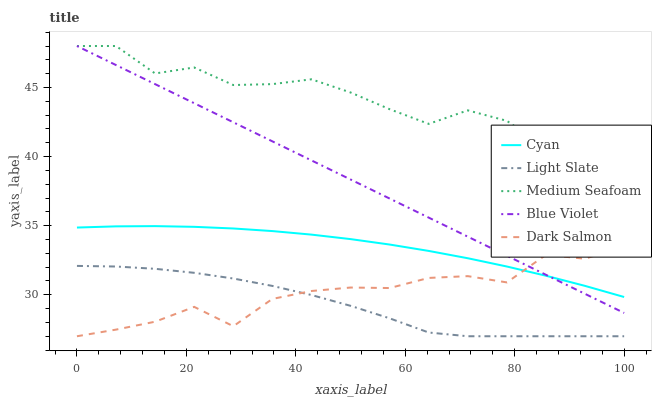Does Light Slate have the minimum area under the curve?
Answer yes or no. Yes. Does Medium Seafoam have the maximum area under the curve?
Answer yes or no. Yes. Does Cyan have the minimum area under the curve?
Answer yes or no. No. Does Cyan have the maximum area under the curve?
Answer yes or no. No. Is Blue Violet the smoothest?
Answer yes or no. Yes. Is Medium Seafoam the roughest?
Answer yes or no. Yes. Is Cyan the smoothest?
Answer yes or no. No. Is Cyan the roughest?
Answer yes or no. No. Does Light Slate have the lowest value?
Answer yes or no. Yes. Does Cyan have the lowest value?
Answer yes or no. No. Does Blue Violet have the highest value?
Answer yes or no. Yes. Does Cyan have the highest value?
Answer yes or no. No. Is Light Slate less than Blue Violet?
Answer yes or no. Yes. Is Medium Seafoam greater than Cyan?
Answer yes or no. Yes. Does Blue Violet intersect Dark Salmon?
Answer yes or no. Yes. Is Blue Violet less than Dark Salmon?
Answer yes or no. No. Is Blue Violet greater than Dark Salmon?
Answer yes or no. No. Does Light Slate intersect Blue Violet?
Answer yes or no. No. 